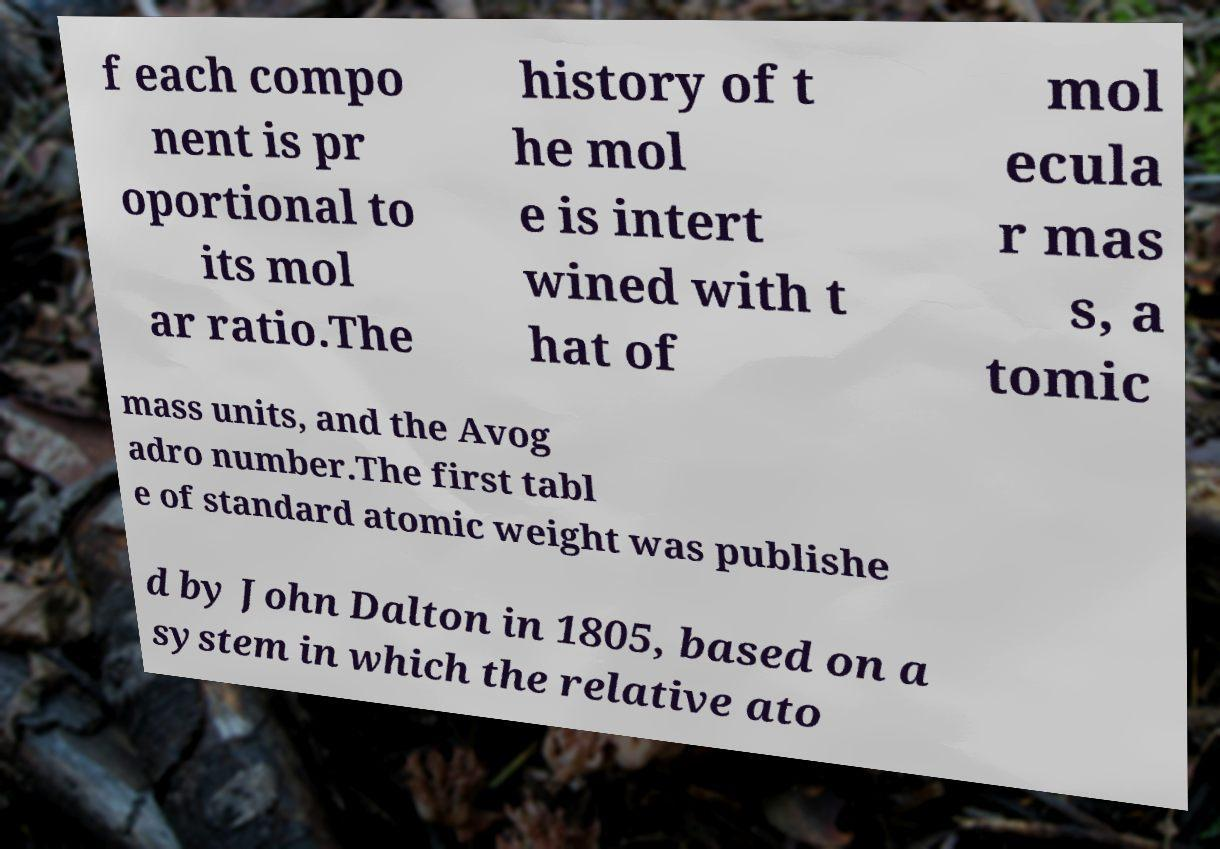Please identify and transcribe the text found in this image. f each compo nent is pr oportional to its mol ar ratio.The history of t he mol e is intert wined with t hat of mol ecula r mas s, a tomic mass units, and the Avog adro number.The first tabl e of standard atomic weight was publishe d by John Dalton in 1805, based on a system in which the relative ato 